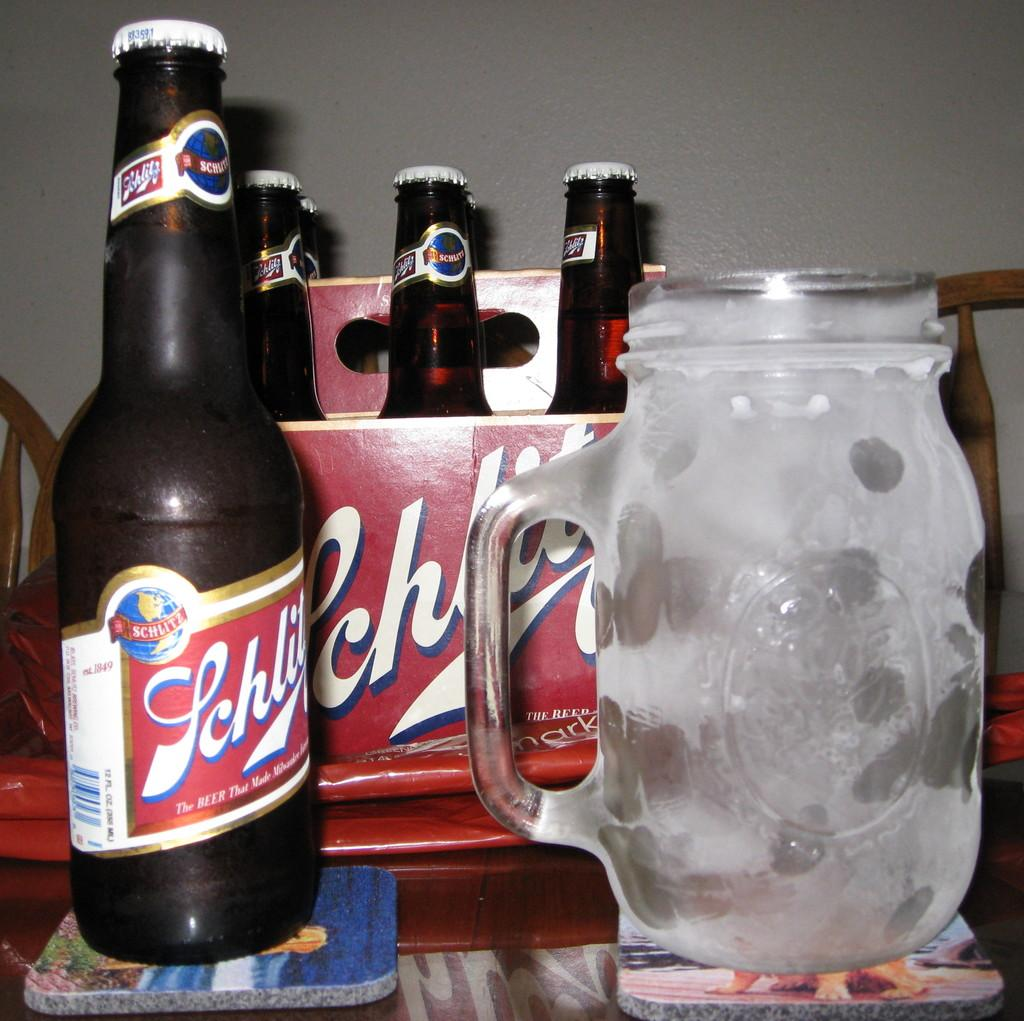Provide a one-sentence caption for the provided image. a case of Schlitz liquor with one bottle out next to a big drinking glass. 